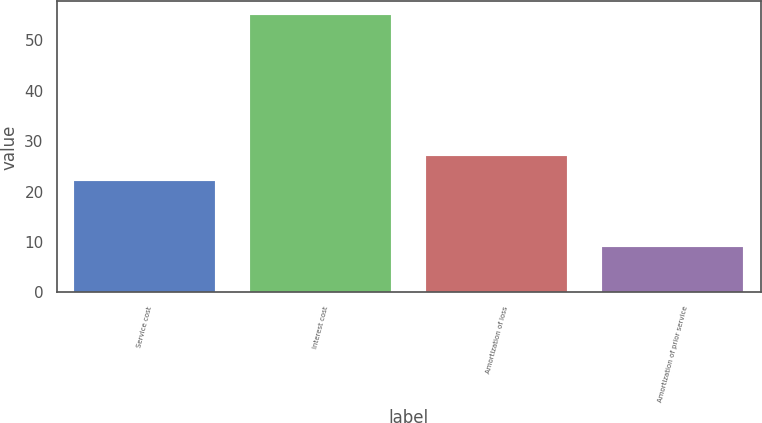Convert chart. <chart><loc_0><loc_0><loc_500><loc_500><bar_chart><fcel>Service cost<fcel>Interest cost<fcel>Amortization of loss<fcel>Amortization of prior service<nl><fcel>22<fcel>55<fcel>27<fcel>9<nl></chart> 